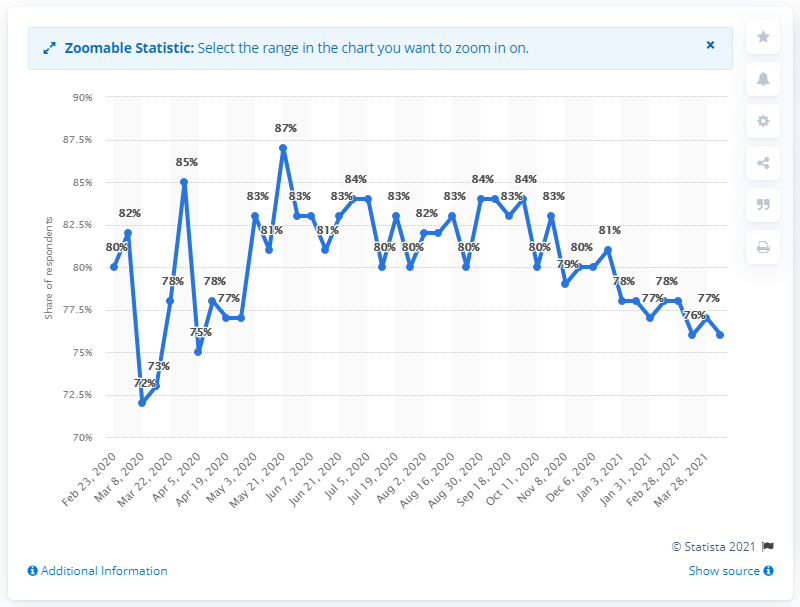List a handful of essential elements in this visual. According to the survey, 76% of Indonesian respondents expressed fear of contracting the coronavirus. The total number of confirmed cases of COVID-19 in Indonesia is 76. 